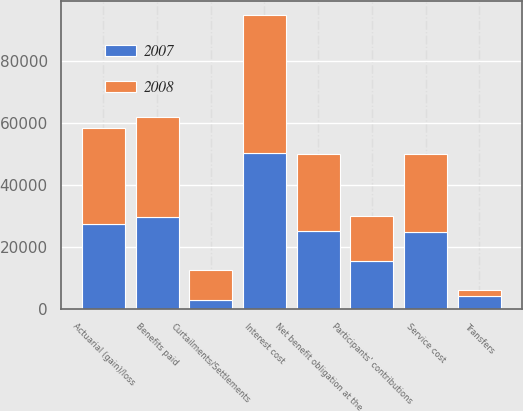Convert chart. <chart><loc_0><loc_0><loc_500><loc_500><stacked_bar_chart><ecel><fcel>Net benefit obligation at the<fcel>Service cost<fcel>Interest cost<fcel>Participants' contributions<fcel>Actuarial (gain)/loss<fcel>Benefits paid<fcel>Curtailments/Settlements<fcel>Transfers<nl><fcel>2007<fcel>25064.5<fcel>24763<fcel>50421<fcel>15518<fcel>27509<fcel>29565<fcel>2791<fcel>4200<nl><fcel>2008<fcel>25064.5<fcel>25366<fcel>44486<fcel>14367<fcel>31029<fcel>32486<fcel>9653<fcel>1868<nl></chart> 